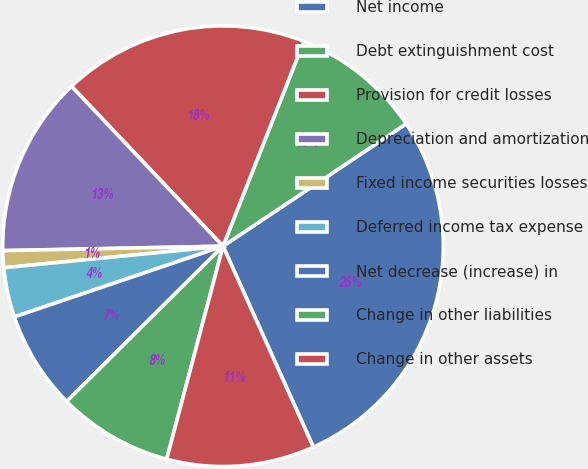<chart> <loc_0><loc_0><loc_500><loc_500><pie_chart><fcel>Net income<fcel>Debt extinguishment cost<fcel>Provision for credit losses<fcel>Depreciation and amortization<fcel>Fixed income securities losses<fcel>Deferred income tax expense<fcel>Net decrease (increase) in<fcel>Change in other liabilities<fcel>Change in other assets<nl><fcel>27.65%<fcel>9.64%<fcel>18.05%<fcel>13.25%<fcel>1.24%<fcel>3.64%<fcel>7.24%<fcel>8.44%<fcel>10.84%<nl></chart> 